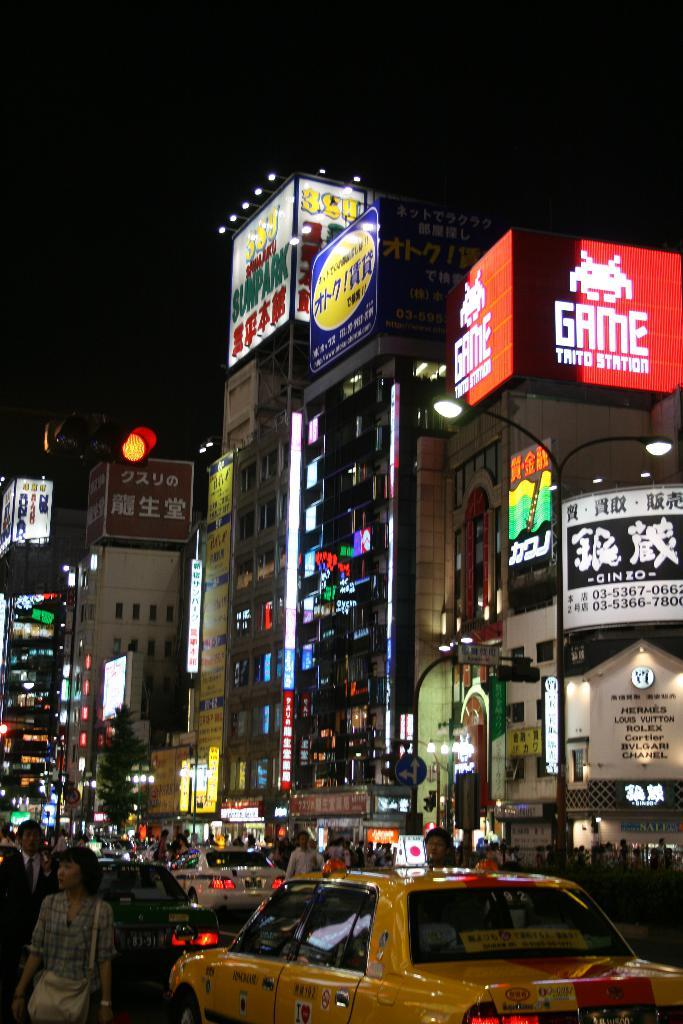<image>
Summarize the visual content of the image. a sign above the street that has the word game on it 